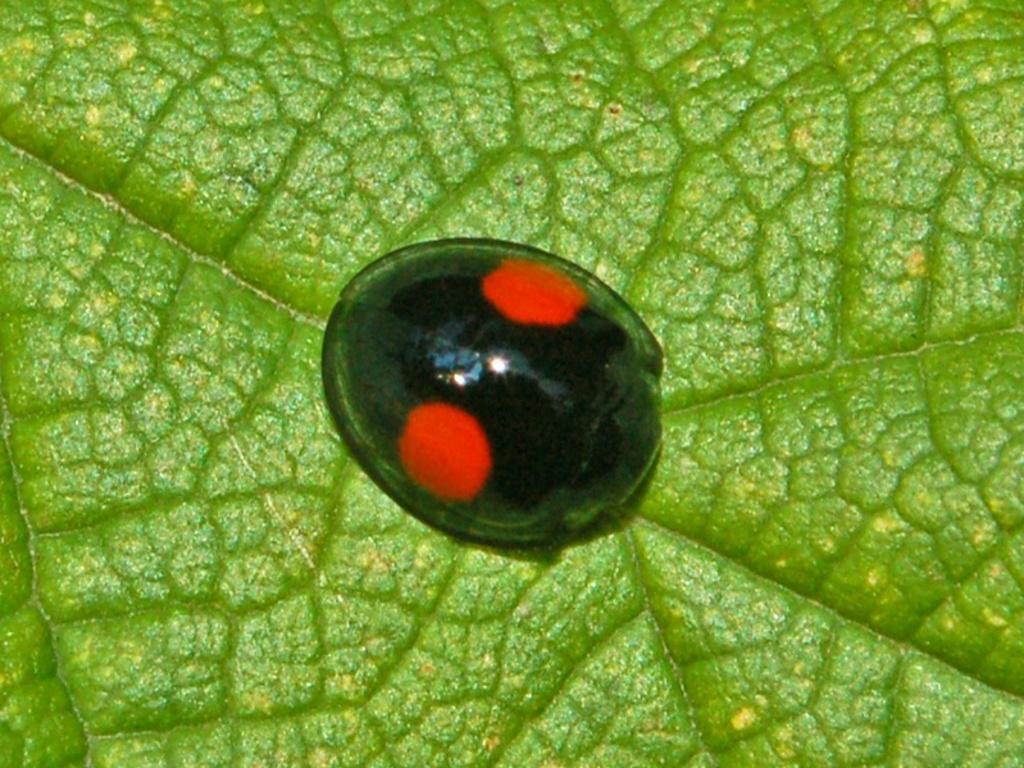What type of creature is present in the image? There is an insect in the image. What colors can be seen on the insect? The insect is black and red in color. Where is the insect located in the image? The insect is on a leaf. What colors can be seen on the leaf? The leaf is green and yellow in color. What type of education does the map in the image provide? There is no map present in the image, so it cannot provide any education. 